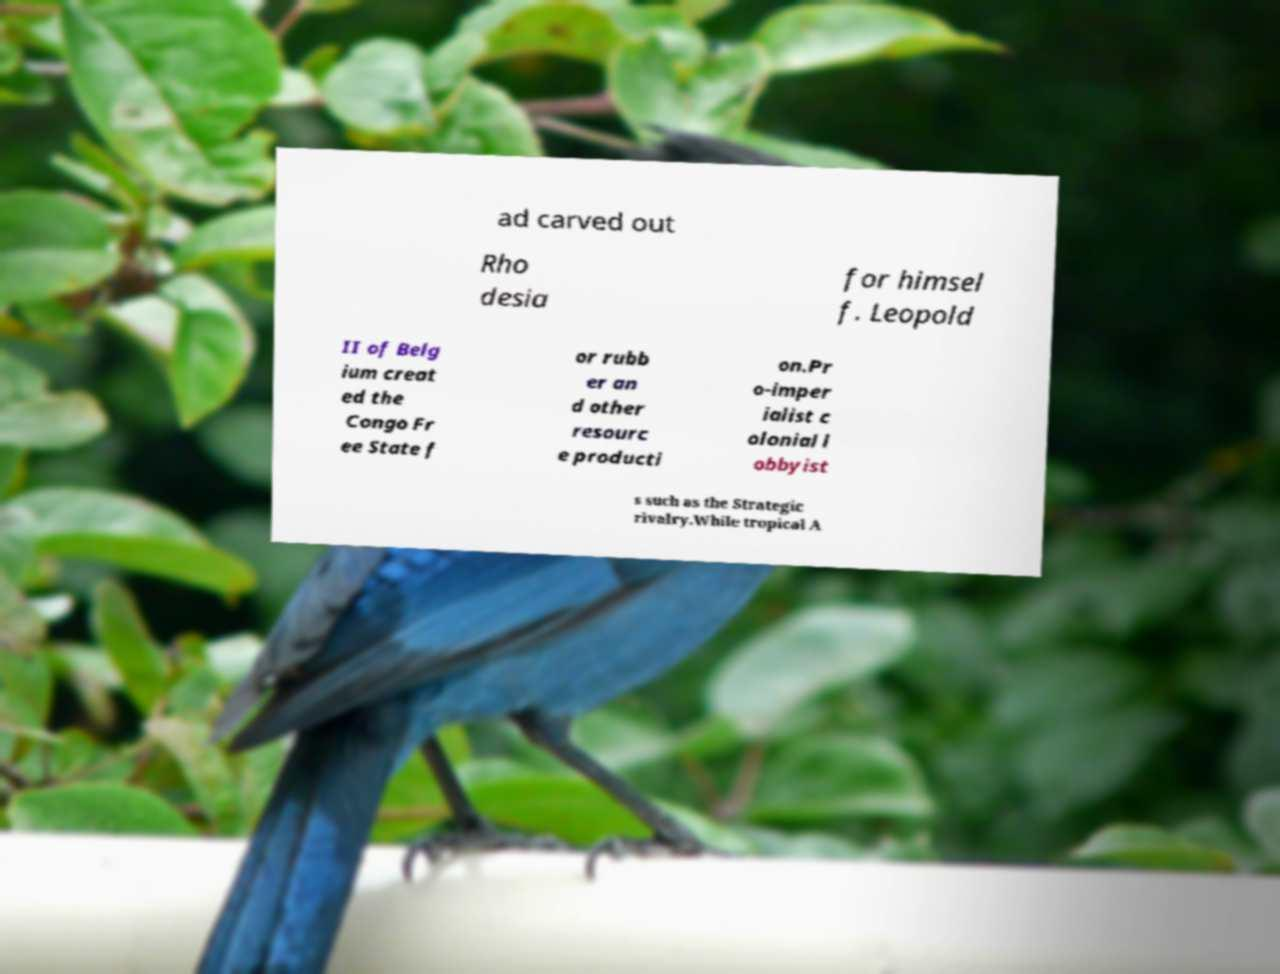Please read and relay the text visible in this image. What does it say? ad carved out Rho desia for himsel f. Leopold II of Belg ium creat ed the Congo Fr ee State f or rubb er an d other resourc e producti on.Pr o-imper ialist c olonial l obbyist s such as the Strategic rivalry.While tropical A 